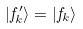Convert formula to latex. <formula><loc_0><loc_0><loc_500><loc_500>| f _ { k } ^ { \prime } \rangle = | f _ { k } \rangle</formula> 